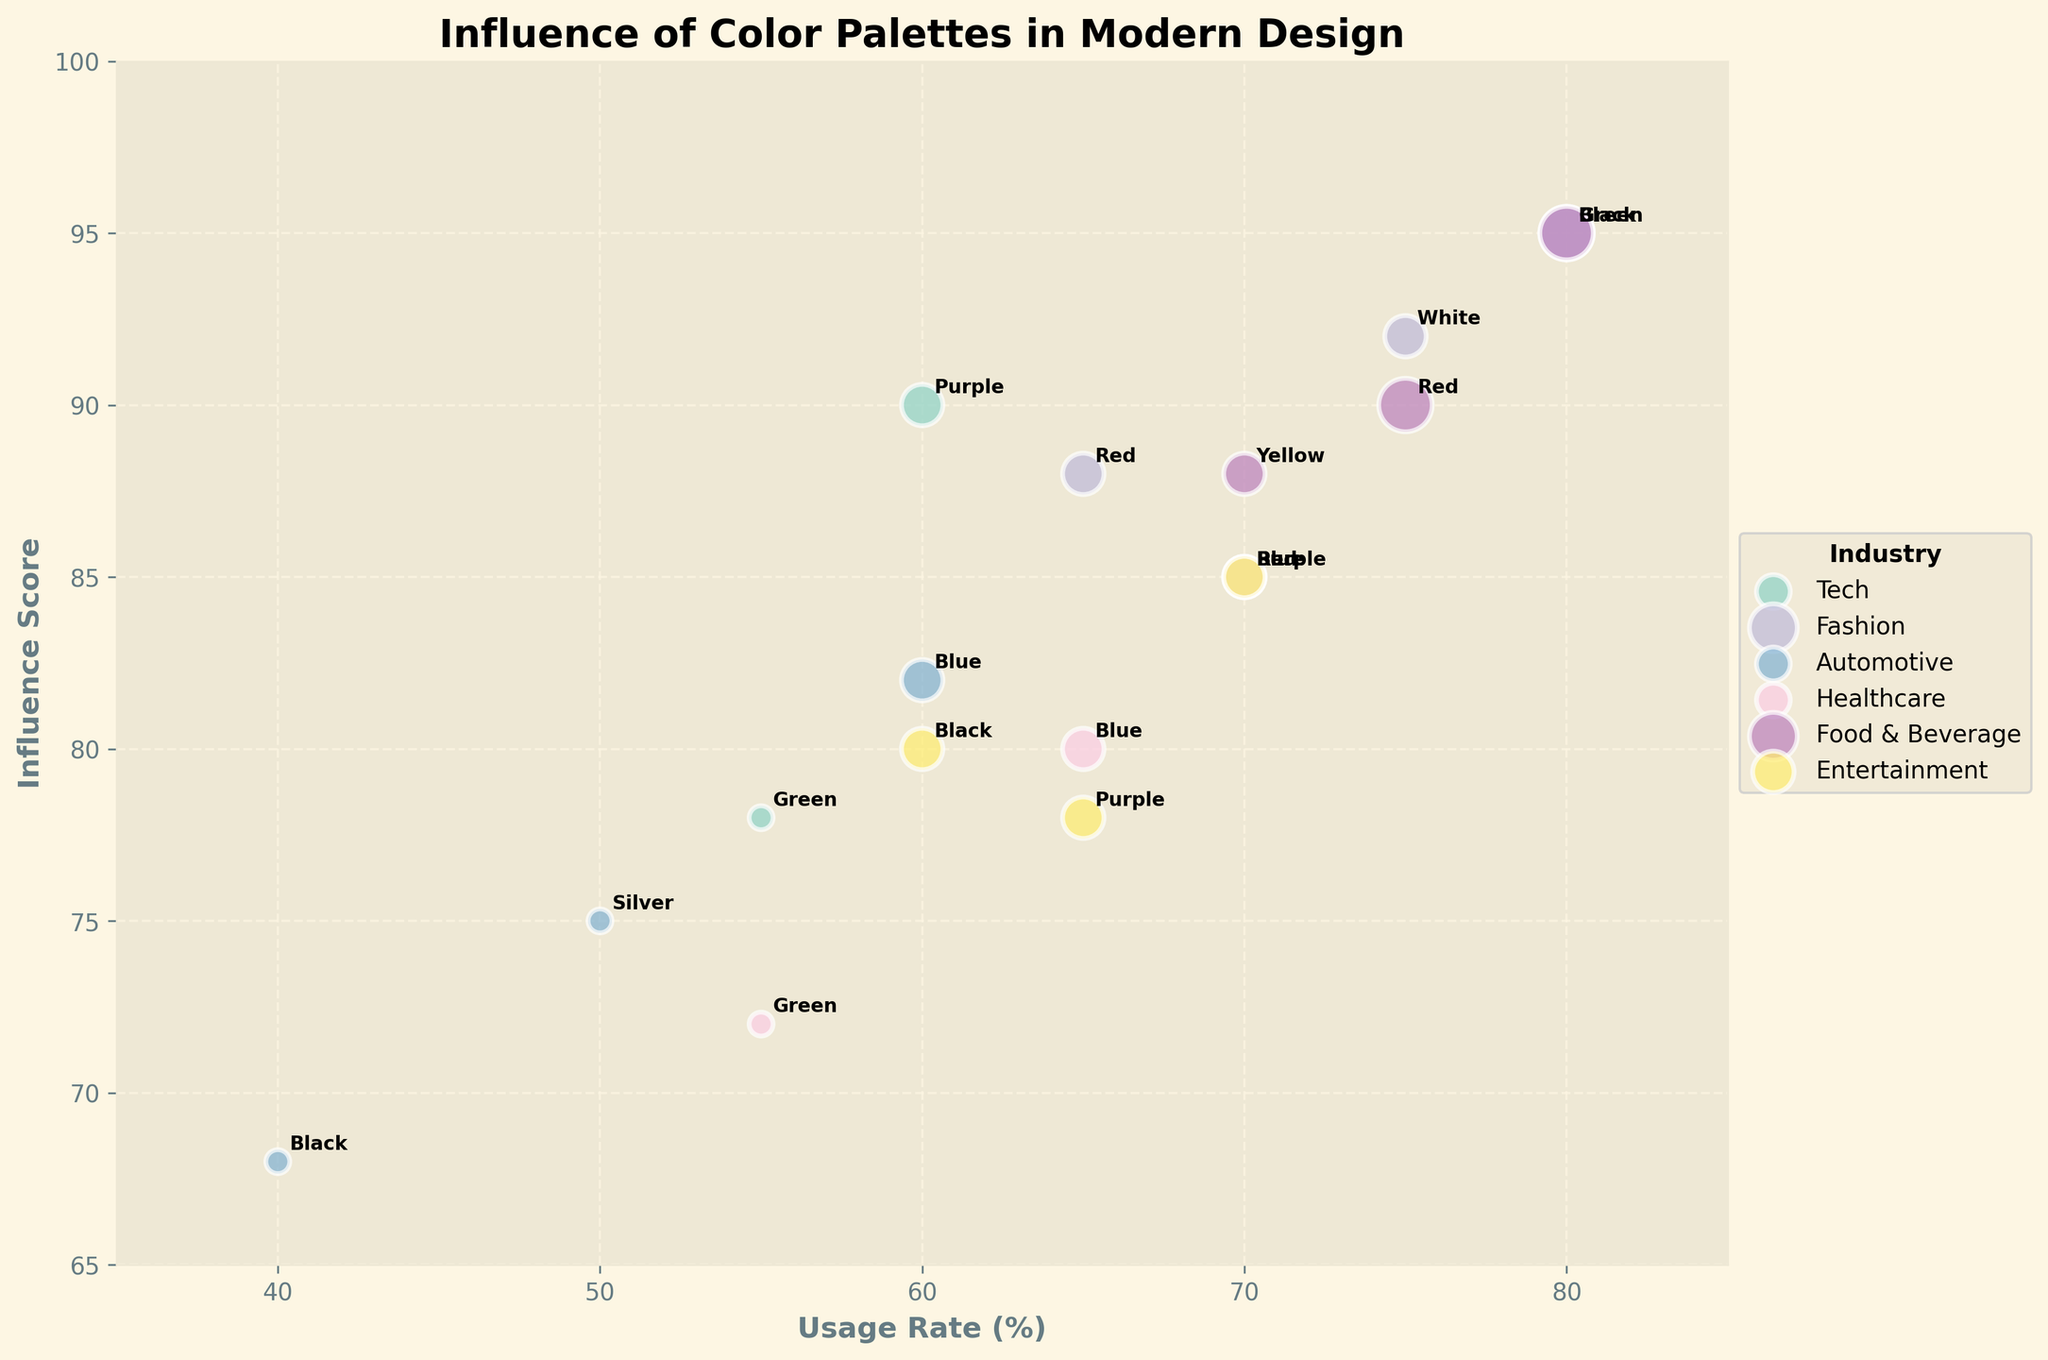What is the title of the chart? The title can be found at the top of the chart, indicating the subject of the visualization
Answer: Influence of Color Palettes in Modern Design Which industry uses Blue the most effectively according to its Branding Effectiveness? By looking at the blue-colored bubbles, we can see which industry uses Blue with the highest Branding Effectiveness. The size of the bubble can indicate effectiveness.
Answer: Tech What is the range of Usage Rate displayed on the x-axis? The x-axis range is indicated by the markings and labels on the horizontal axis
Answer: 35 to 85 Which two industries have Red as a key color, and how do they differ in Influence Score? By identifying the bubbles labeled 'Red' and checking their respective positions, we can determine the involved industries and look at their vertical positions (Influence Score).
Answer: Fashion and Entertainment Arrange the industries in descending order based on their highest Influence Score. Identify the highest y-value for each industry and arrange them accordingly
Answer: Fashion, Food & Beverage, Tech, Healthcare, Entertainment, Automotive How does Healthcare's Branding Effectiveness for Purple compare to Tech's? Compare the bubble sizes labeled 'Purple' for Healthcare and Tech. Larger bubbles indicate higher Branding Effectiveness.
Answer: Equal (both High) Calculate the average Influence Score of the Fashion industry. Sum the Influence Scores for Fashion and divide by the number of data points in this industry
Answer: (95 + 88 + 92) / 3 = 91.67 Which industry has the most diverse range of Key Colors? Identify the industry with the most varied color labels shown in the annotations
Answer: Tech What is the maximum Usage Rate among the Automotive industry entries? Check the x-values for the Automotive industry and identify the maximum value
Answer: 60 Which color in the Food & Beverage industry has the highest Branding Effectiveness? Look at the size of the bubbles in the Food & Beverage industry and identify the largest bubble's color
Answer: Green 